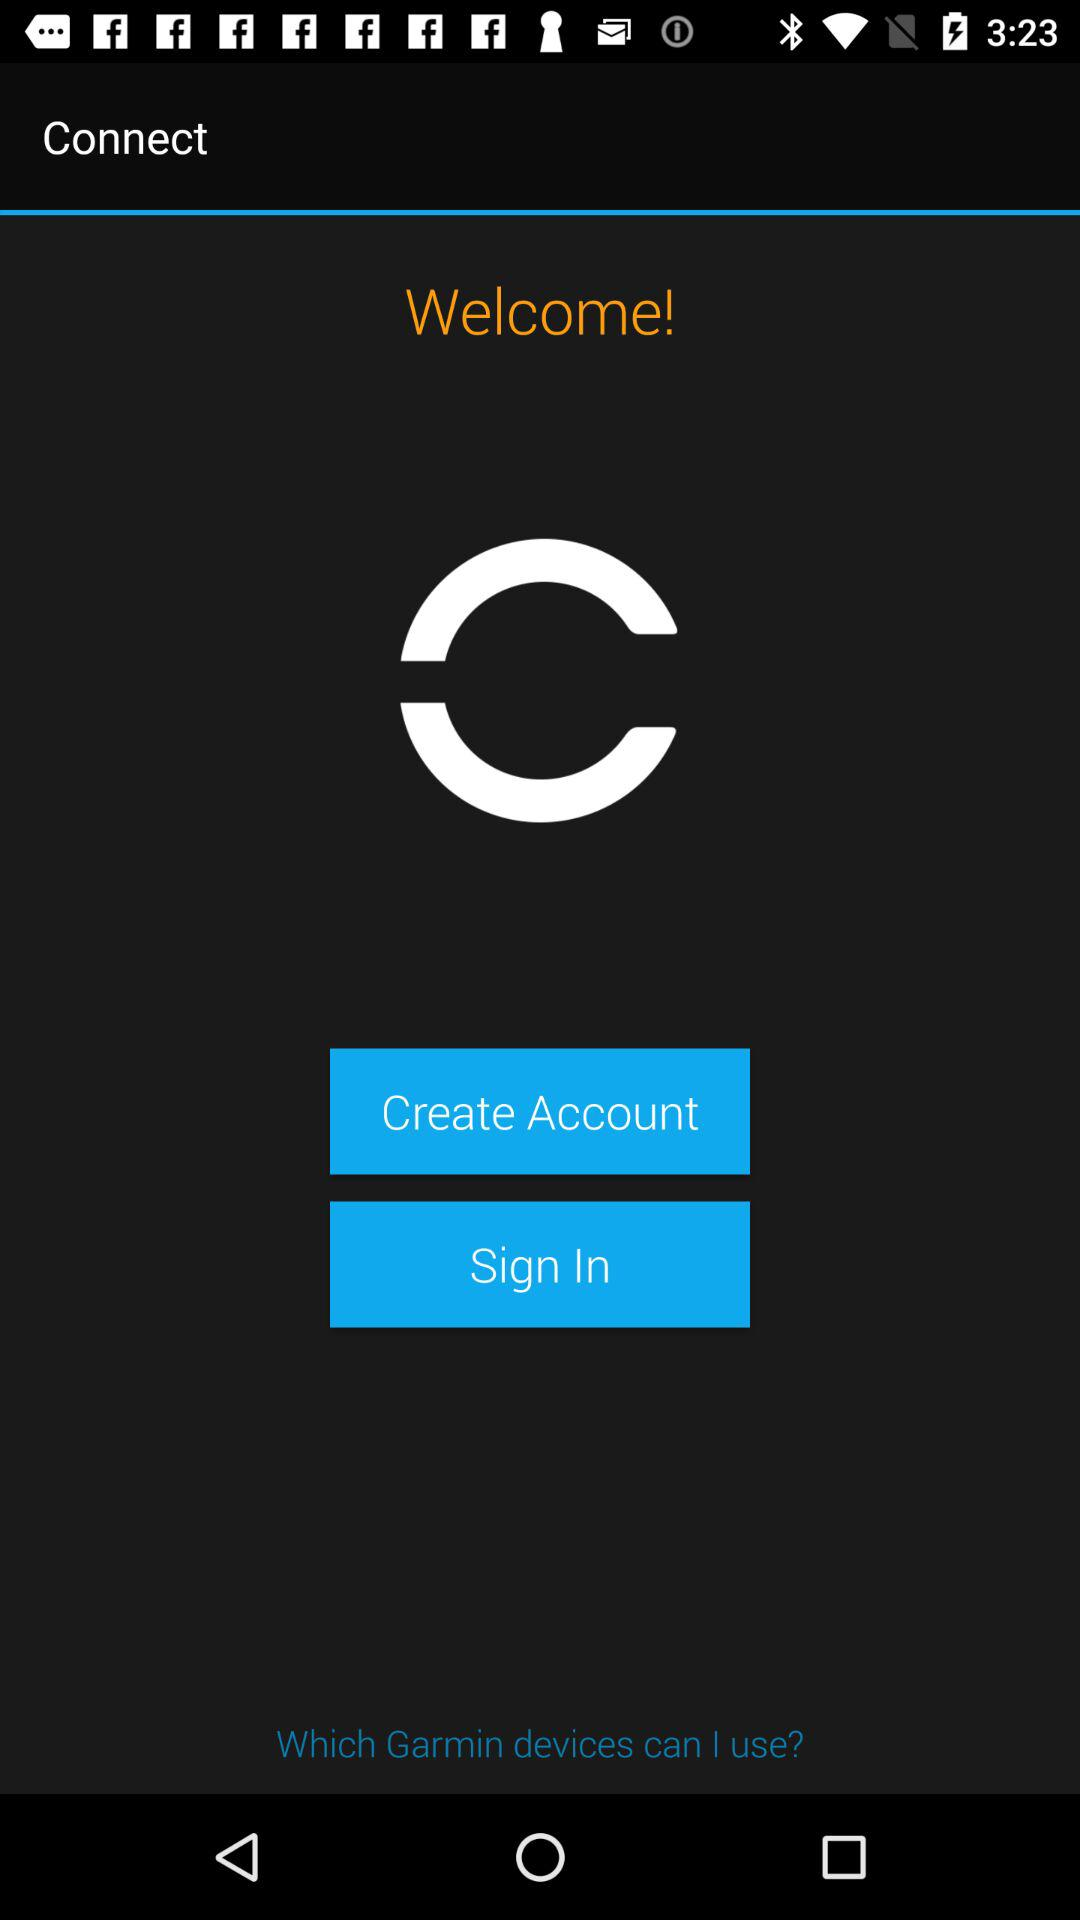How can I connect the account?
When the provided information is insufficient, respond with <no answer>. <no answer> 